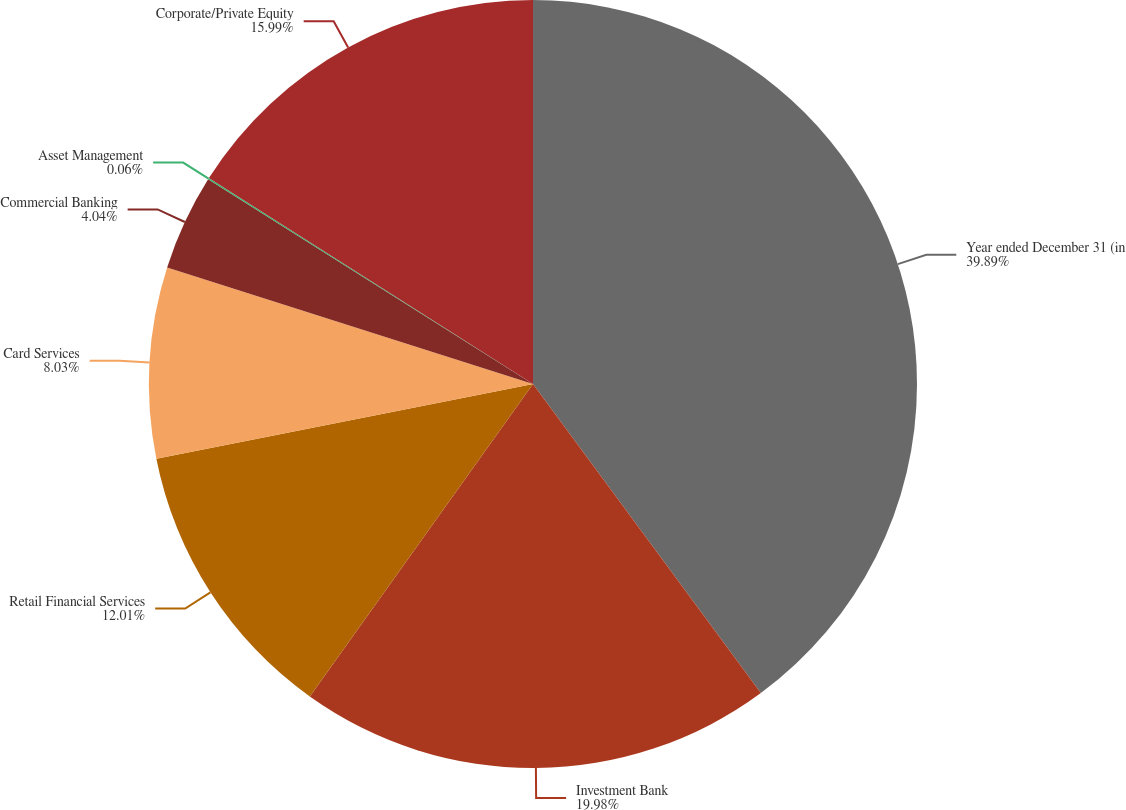<chart> <loc_0><loc_0><loc_500><loc_500><pie_chart><fcel>Year ended December 31 (in<fcel>Investment Bank<fcel>Retail Financial Services<fcel>Card Services<fcel>Commercial Banking<fcel>Asset Management<fcel>Corporate/Private Equity<nl><fcel>39.89%<fcel>19.98%<fcel>12.01%<fcel>8.03%<fcel>4.04%<fcel>0.06%<fcel>15.99%<nl></chart> 